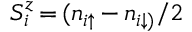<formula> <loc_0><loc_0><loc_500><loc_500>S _ { i } ^ { z } \, { = } \, ( n _ { i \uparrow } \, { - } \, n _ { i \downarrow ) } / 2</formula> 